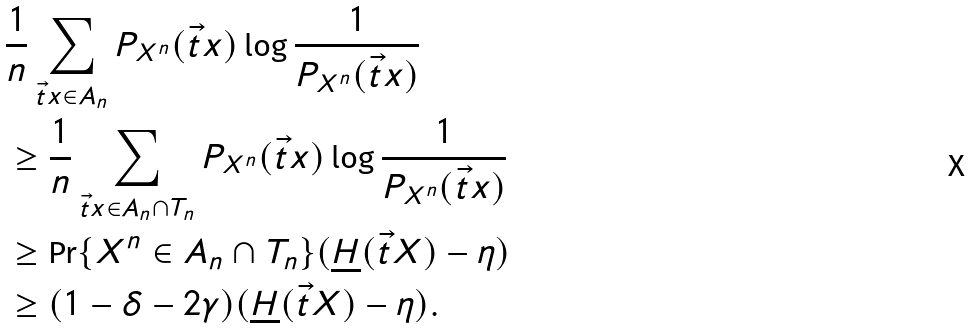Convert formula to latex. <formula><loc_0><loc_0><loc_500><loc_500>& \frac { 1 } { n } \sum _ { \vec { t } { x } \in A _ { n } } P _ { X ^ { n } } ( \vec { t } { x } ) \log \frac { 1 } { P _ { X ^ { n } } ( \vec { t } { x } ) } \\ & \geq \frac { 1 } { n } \sum _ { \vec { t } { x } \in A _ { n } \cap T _ { n } } P _ { X ^ { n } } ( \vec { t } { x } ) \log \frac { 1 } { P _ { X ^ { n } } ( \vec { t } { x } ) } \\ & \geq \Pr \{ X ^ { n } \in A _ { n } \cap T _ { n } \} ( \underline { H } ( \vec { t } { X } ) - \eta ) \\ & \geq ( 1 - \delta - 2 \gamma ) ( \underline { H } ( \vec { t } { X } ) - \eta ) .</formula> 